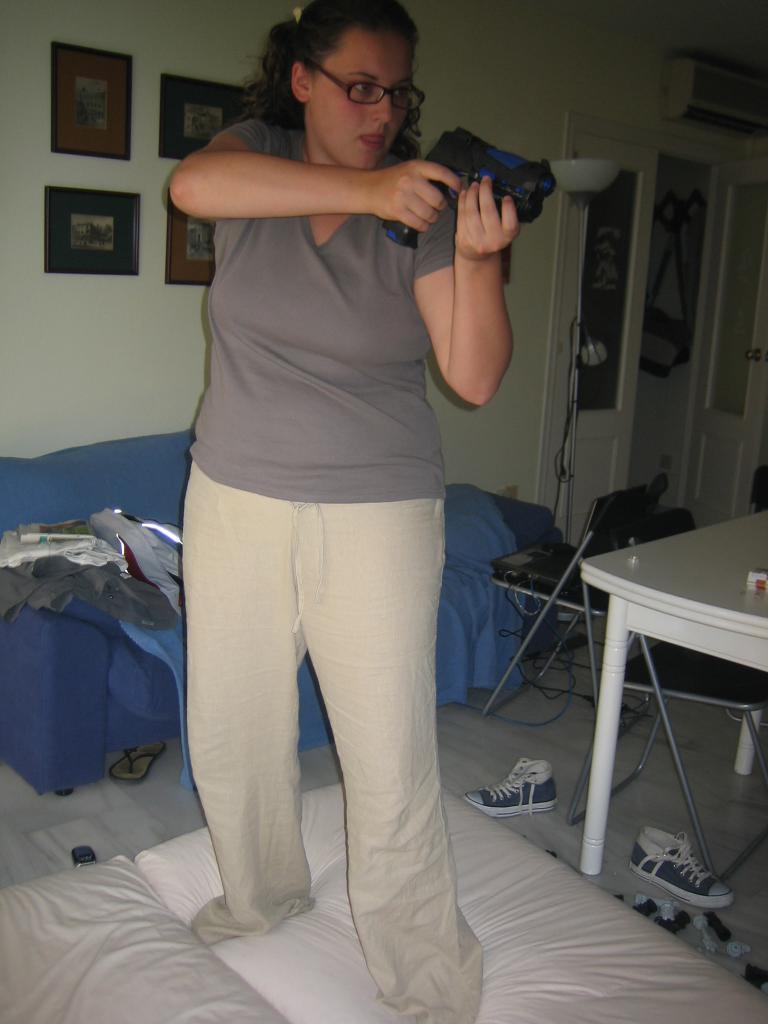Can you describe this image briefly? In this image I can see a woman wearing a t-shirt and standing on the bed by holding a gun in her hands. This is an image clicked inside the room. On the right side of this image there is a table. At the back of her there is a blue color couch. In the background there is a wall and few frames are attached to it. 